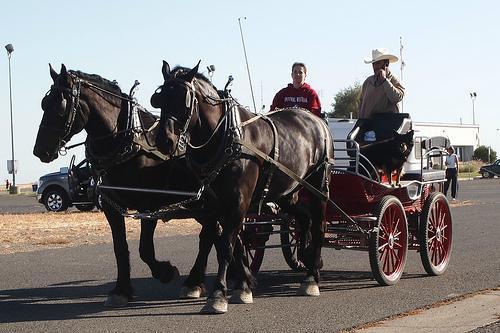How many horses are there?
Give a very brief answer. 2. 